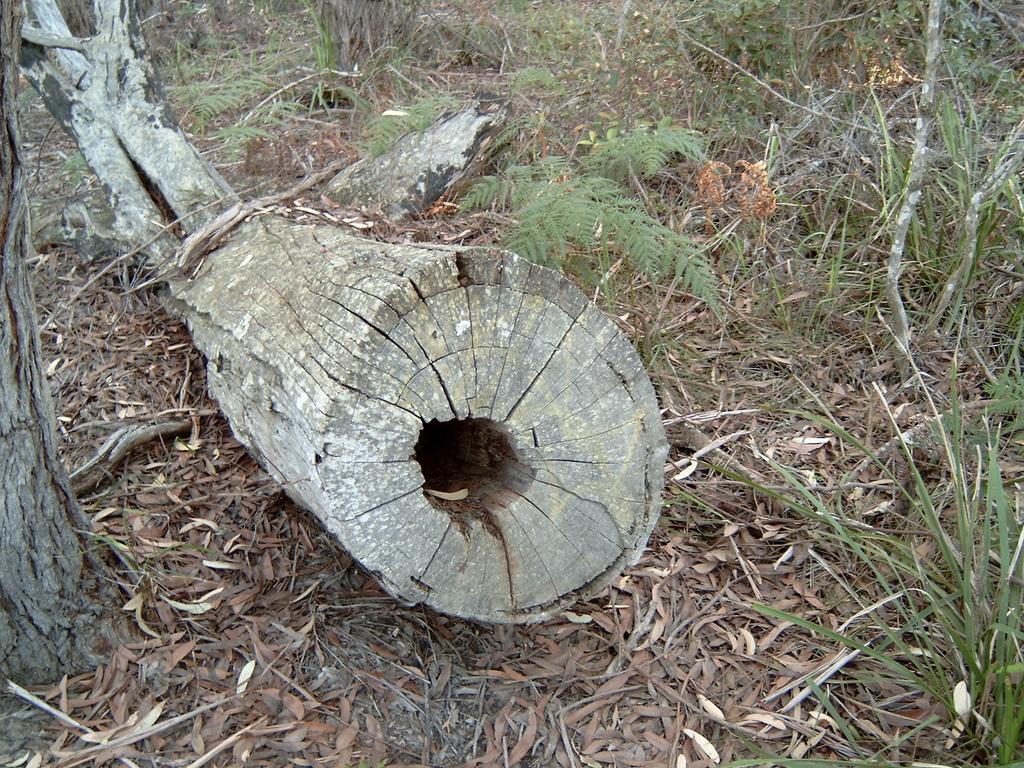Please provide a concise description of this image. In the foreground of this picture, there is a trunk on the ground. In the background, there are grass and sticks. 